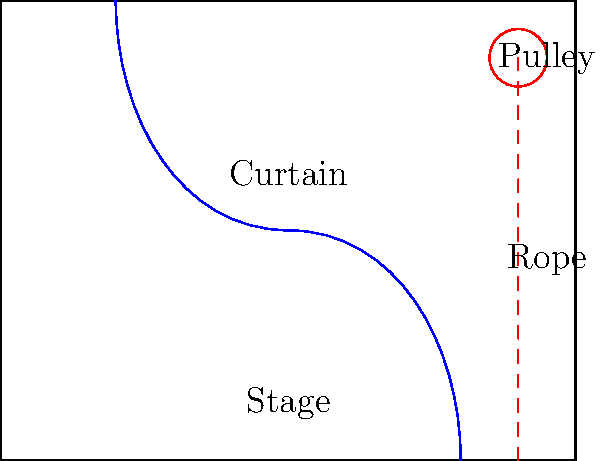In a Broadway stage curtain system, the main curtain is raised and lowered using a pulley mechanism. If the curtain weighs 500 lbs and needs to be raised 20 feet, what is the minimum work required to lift the curtain, assuming ideal conditions and neglecting friction? To solve this problem, we'll use the principle of work in mechanical systems. Work is defined as the force applied multiplied by the distance moved in the direction of the force.

Step 1: Identify the known variables
- Weight of the curtain (W) = 500 lbs
- Height to raise the curtain (h) = 20 feet

Step 2: Recall the formula for work
Work (W) = Force (F) × Distance (d)

Step 3: In this case, the force required is equal to the weight of the curtain, and the distance is the height it needs to be raised.
W = 500 lbs × 20 feet

Step 4: Calculate the work
W = 10,000 ft-lbs

Note: In an ideal pulley system (neglecting friction and assuming 100% efficiency), the work input equals the work output. Therefore, the minimum work required is equal to the work done against gravity to lift the curtain.
Answer: 10,000 ft-lbs 